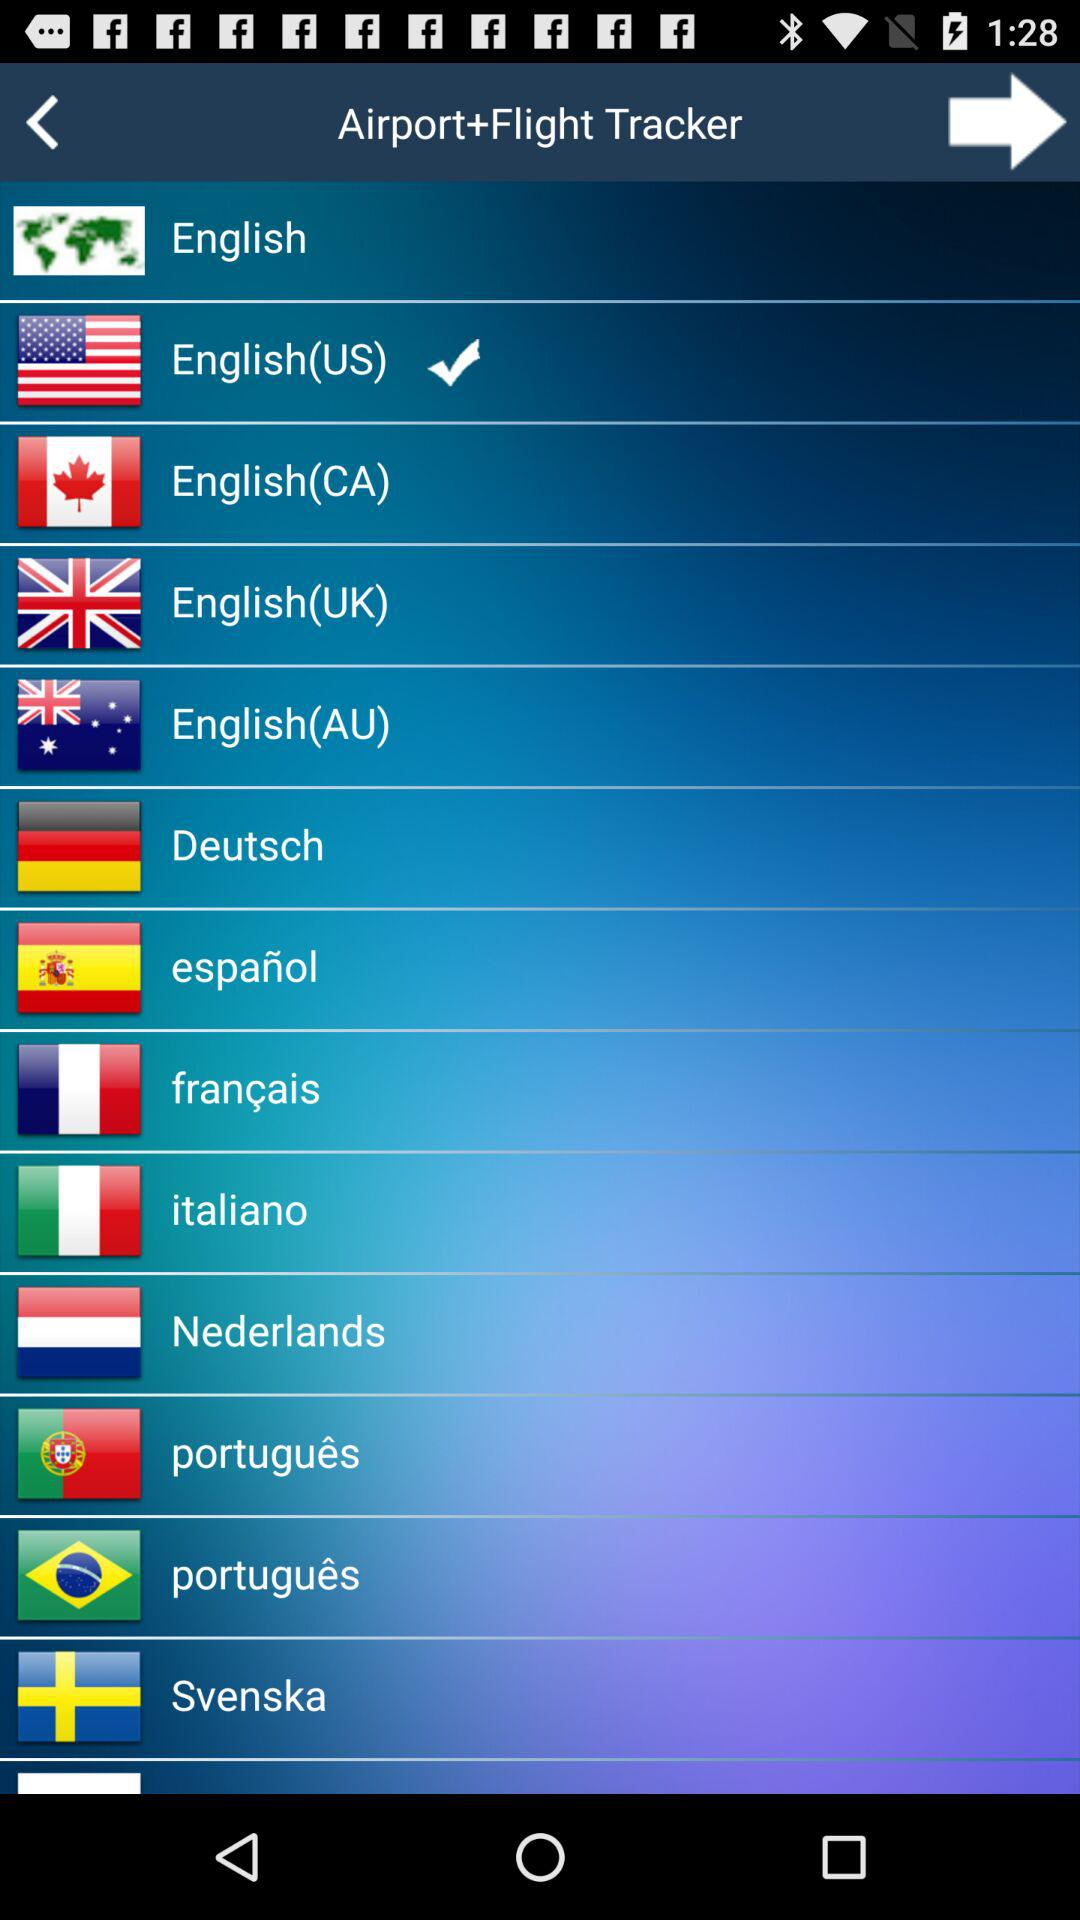Which option is marked as checked? The option "English(US)" is marked as checked. 